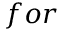<formula> <loc_0><loc_0><loc_500><loc_500>f o r</formula> 